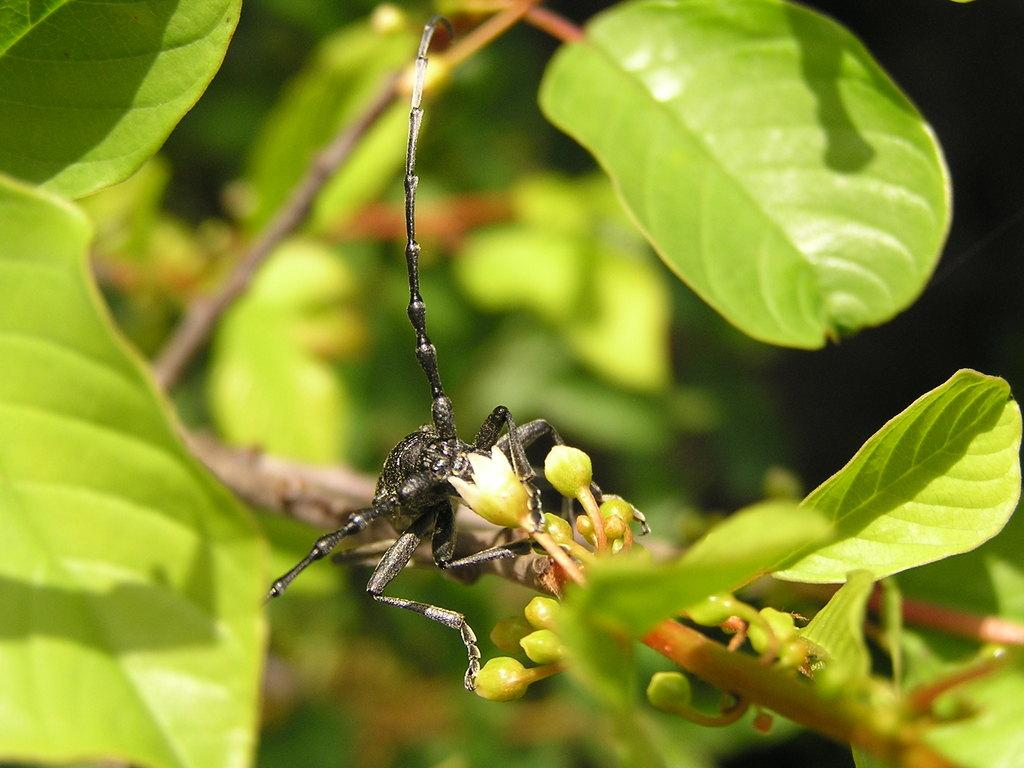What is the main subject of focus of the image? The main focus of the image is an insect. Where is the insect located in the image? The insect is on a stem in the center of the image. What can be seen around the insect in the image? There are leaves around the area of the image. What type of coal is visible in the image? There is no coal present in the image; it features an insect on a stem surrounded by leaves. 